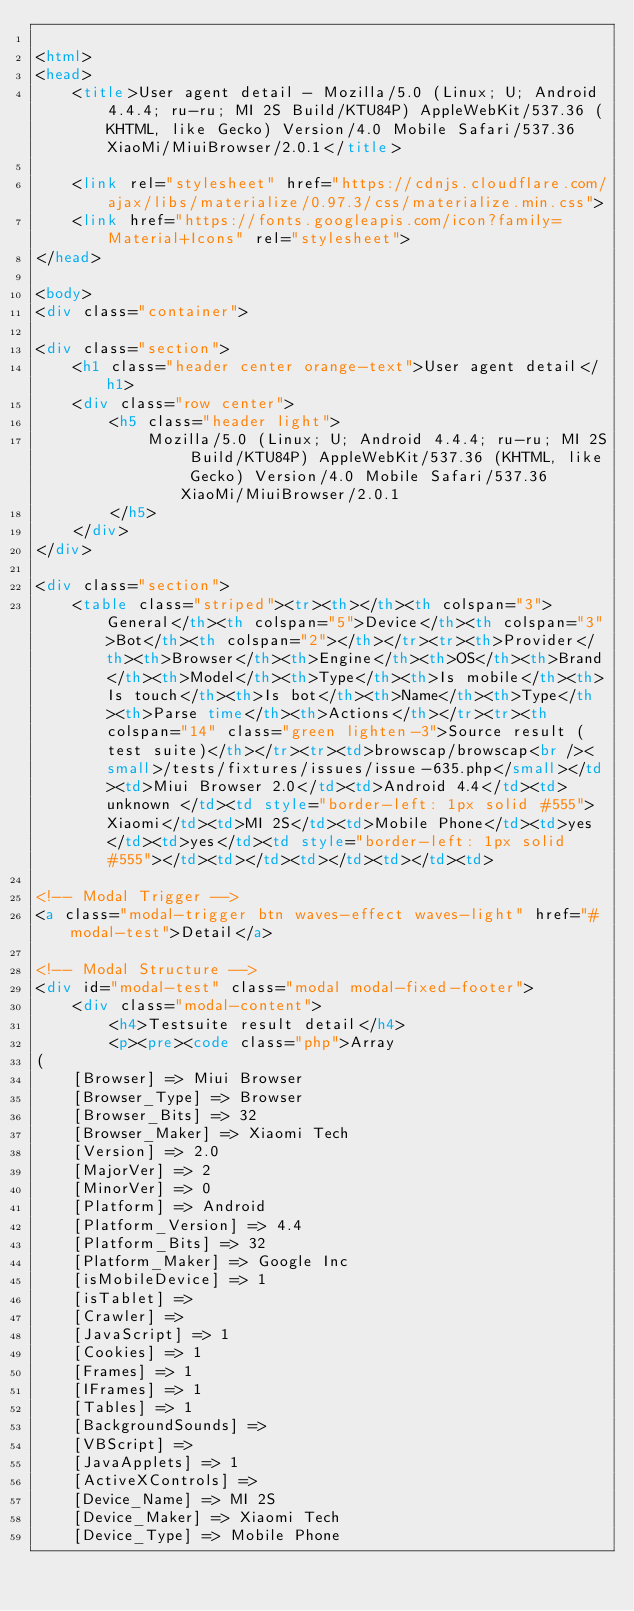Convert code to text. <code><loc_0><loc_0><loc_500><loc_500><_HTML_>
<html>
<head>
    <title>User agent detail - Mozilla/5.0 (Linux; U; Android 4.4.4; ru-ru; MI 2S Build/KTU84P) AppleWebKit/537.36 (KHTML, like Gecko) Version/4.0 Mobile Safari/537.36 XiaoMi/MiuiBrowser/2.0.1</title>
        
    <link rel="stylesheet" href="https://cdnjs.cloudflare.com/ajax/libs/materialize/0.97.3/css/materialize.min.css">
    <link href="https://fonts.googleapis.com/icon?family=Material+Icons" rel="stylesheet">
</head>
        
<body>
<div class="container">
    
<div class="section">
	<h1 class="header center orange-text">User agent detail</h1>
	<div class="row center">
        <h5 class="header light">
            Mozilla/5.0 (Linux; U; Android 4.4.4; ru-ru; MI 2S Build/KTU84P) AppleWebKit/537.36 (KHTML, like Gecko) Version/4.0 Mobile Safari/537.36 XiaoMi/MiuiBrowser/2.0.1
        </h5>
	</div>
</div>   

<div class="section">
    <table class="striped"><tr><th></th><th colspan="3">General</th><th colspan="5">Device</th><th colspan="3">Bot</th><th colspan="2"></th></tr><tr><th>Provider</th><th>Browser</th><th>Engine</th><th>OS</th><th>Brand</th><th>Model</th><th>Type</th><th>Is mobile</th><th>Is touch</th><th>Is bot</th><th>Name</th><th>Type</th><th>Parse time</th><th>Actions</th></tr><tr><th colspan="14" class="green lighten-3">Source result (test suite)</th></tr><tr><td>browscap/browscap<br /><small>/tests/fixtures/issues/issue-635.php</small></td><td>Miui Browser 2.0</td><td>Android 4.4</td><td>unknown </td><td style="border-left: 1px solid #555">Xiaomi</td><td>MI 2S</td><td>Mobile Phone</td><td>yes</td><td>yes</td><td style="border-left: 1px solid #555"></td><td></td><td></td><td></td><td>
                
<!-- Modal Trigger -->
<a class="modal-trigger btn waves-effect waves-light" href="#modal-test">Detail</a>

<!-- Modal Structure -->
<div id="modal-test" class="modal modal-fixed-footer">
    <div class="modal-content">
        <h4>Testsuite result detail</h4>
        <p><pre><code class="php">Array
(
    [Browser] => Miui Browser
    [Browser_Type] => Browser
    [Browser_Bits] => 32
    [Browser_Maker] => Xiaomi Tech
    [Version] => 2.0
    [MajorVer] => 2
    [MinorVer] => 0
    [Platform] => Android
    [Platform_Version] => 4.4
    [Platform_Bits] => 32
    [Platform_Maker] => Google Inc
    [isMobileDevice] => 1
    [isTablet] => 
    [Crawler] => 
    [JavaScript] => 1
    [Cookies] => 1
    [Frames] => 1
    [IFrames] => 1
    [Tables] => 1
    [BackgroundSounds] => 
    [VBScript] => 
    [JavaApplets] => 1
    [ActiveXControls] => 
    [Device_Name] => MI 2S
    [Device_Maker] => Xiaomi Tech
    [Device_Type] => Mobile Phone</code> 